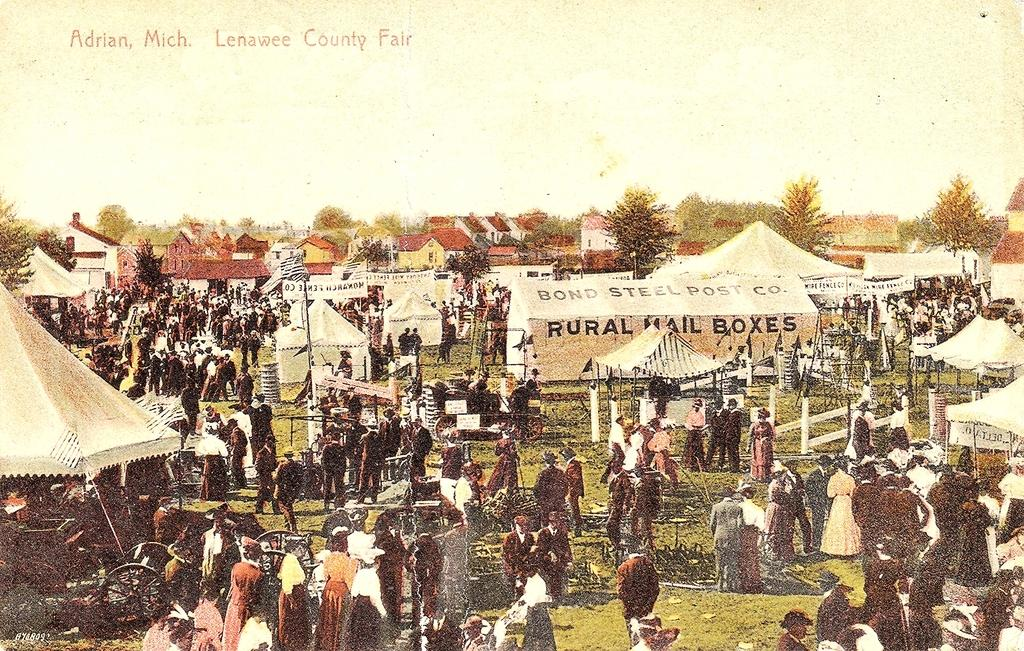<image>
Provide a brief description of the given image. the Lenawee county fair was full of many people 